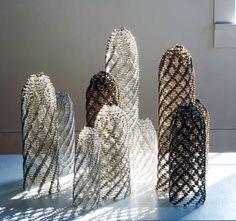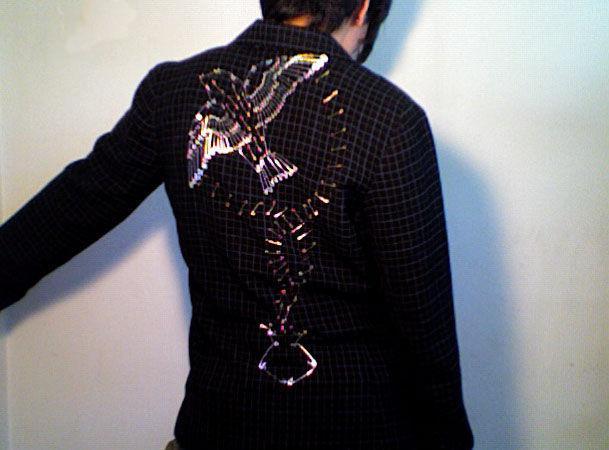The first image is the image on the left, the second image is the image on the right. Examine the images to the left and right. Is the description "A woman models the back of a jacket decorated with pins in the shape of a complete bird." accurate? Answer yes or no. Yes. The first image is the image on the left, the second image is the image on the right. Analyze the images presented: Is the assertion "One image contains a person wearing a black jacket with a bird design on it." valid? Answer yes or no. Yes. 